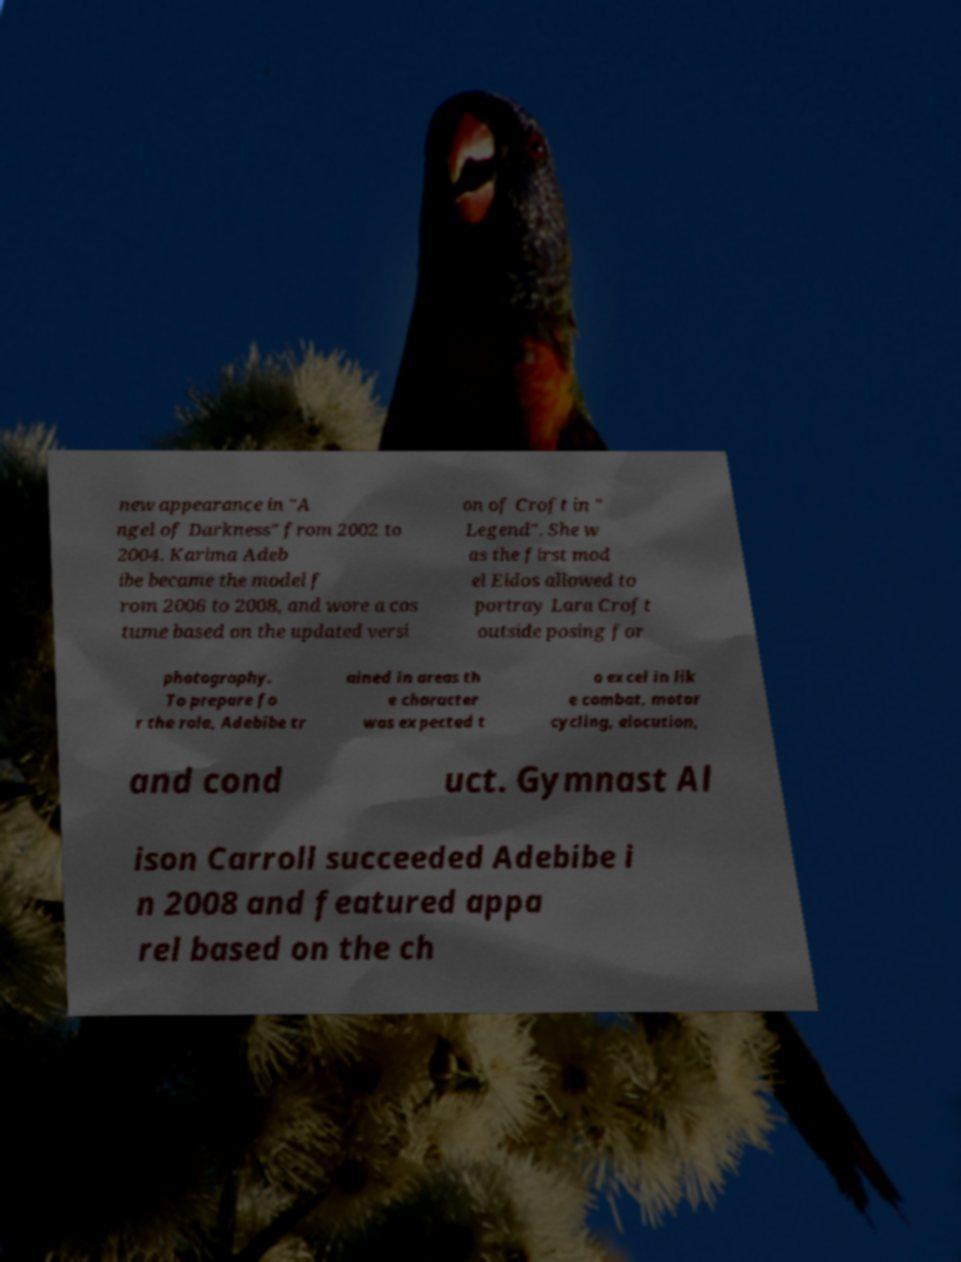Please identify and transcribe the text found in this image. new appearance in "A ngel of Darkness" from 2002 to 2004. Karima Adeb ibe became the model f rom 2006 to 2008, and wore a cos tume based on the updated versi on of Croft in " Legend". She w as the first mod el Eidos allowed to portray Lara Croft outside posing for photography. To prepare fo r the role, Adebibe tr ained in areas th e character was expected t o excel in lik e combat, motor cycling, elocution, and cond uct. Gymnast Al ison Carroll succeeded Adebibe i n 2008 and featured appa rel based on the ch 